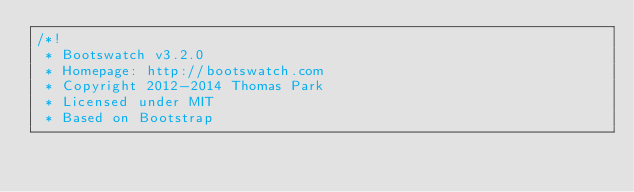<code> <loc_0><loc_0><loc_500><loc_500><_CSS_>/*!
 * Bootswatch v3.2.0
 * Homepage: http://bootswatch.com
 * Copyright 2012-2014 Thomas Park
 * Licensed under MIT
 * Based on Bootstrap</code> 